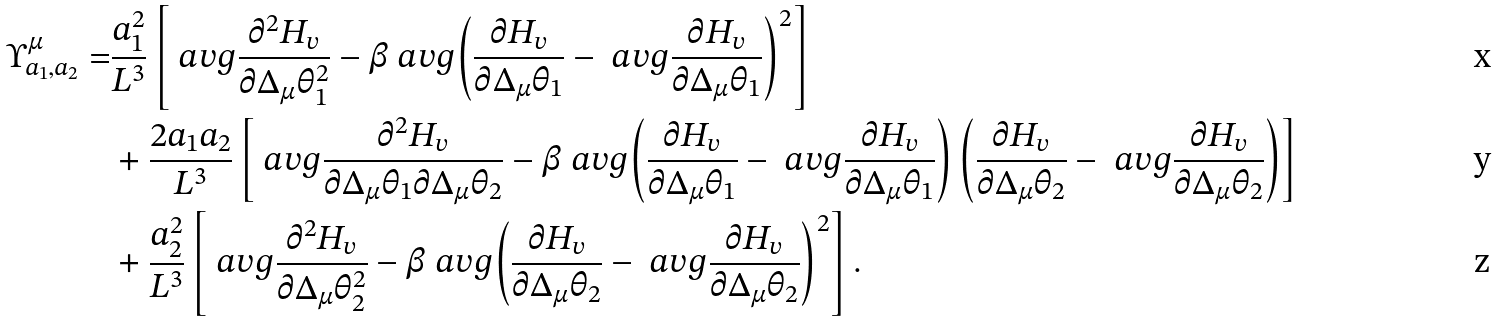<formula> <loc_0><loc_0><loc_500><loc_500>\Upsilon ^ { \mu } _ { a _ { 1 } , a _ { 2 } } = & \frac { a _ { 1 } ^ { 2 } } { L ^ { 3 } } \left [ \ a v g { \frac { \partial ^ { 2 } H _ { v } } { \partial \Delta _ { \mu } \theta _ { 1 } ^ { 2 } } } - \beta \ a v g { \left ( \frac { \partial H _ { v } } { \partial \Delta _ { \mu } \theta _ { 1 } } - \ a v g { \frac { \partial H _ { v } } { \partial \Delta _ { \mu } \theta _ { 1 } } } \right ) ^ { 2 } } \right ] \\ & + \frac { 2 a _ { 1 } a _ { 2 } } { L ^ { 3 } } \left [ \ a v g { \frac { \partial ^ { 2 } H _ { v } } { \partial \Delta _ { \mu } \theta _ { 1 } \partial \Delta _ { \mu } \theta _ { 2 } } } - \beta \ a v g { \left ( \frac { \partial H _ { v } } { \partial \Delta _ { \mu } \theta _ { 1 } } - \ a v g { \frac { \partial H _ { v } } { \partial \Delta _ { \mu } \theta _ { 1 } } } \right ) \left ( \frac { \partial H _ { v } } { \partial \Delta _ { \mu } \theta _ { 2 } } - \ a v g { \frac { \partial H _ { v } } { \partial \Delta _ { \mu } \theta _ { 2 } } } \right ) } \right ] \\ & + \frac { a _ { 2 } ^ { 2 } } { L ^ { 3 } } \left [ \ a v g { \frac { \partial ^ { 2 } H _ { v } } { \partial \Delta _ { \mu } \theta _ { 2 } ^ { 2 } } } - \beta \ a v g { \left ( \frac { \partial H _ { v } } { \partial \Delta _ { \mu } \theta _ { 2 } } - \ a v g { \frac { \partial H _ { v } } { \partial \Delta _ { \mu } \theta _ { 2 } } } \right ) ^ { 2 } } \right ] .</formula> 